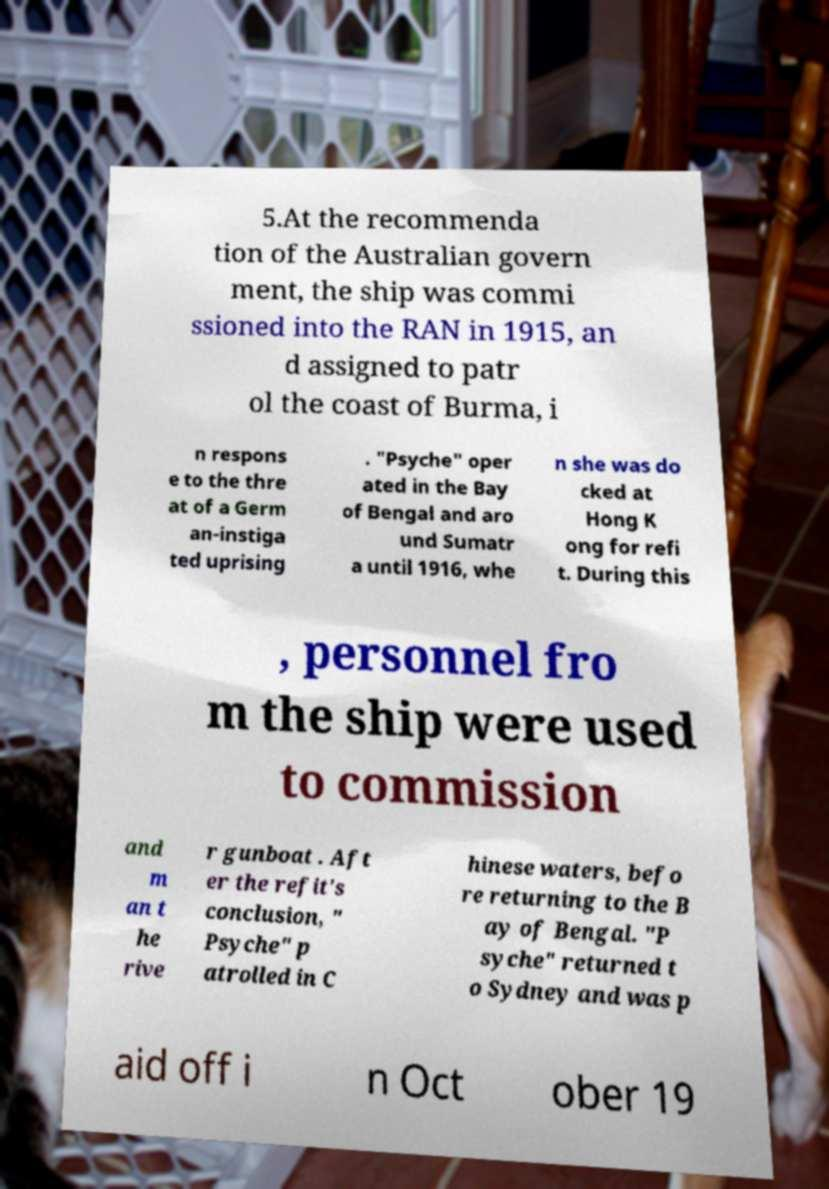I need the written content from this picture converted into text. Can you do that? 5.At the recommenda tion of the Australian govern ment, the ship was commi ssioned into the RAN in 1915, an d assigned to patr ol the coast of Burma, i n respons e to the thre at of a Germ an-instiga ted uprising . "Psyche" oper ated in the Bay of Bengal and aro und Sumatr a until 1916, whe n she was do cked at Hong K ong for refi t. During this , personnel fro m the ship were used to commission and m an t he rive r gunboat . Aft er the refit's conclusion, " Psyche" p atrolled in C hinese waters, befo re returning to the B ay of Bengal. "P syche" returned t o Sydney and was p aid off i n Oct ober 19 